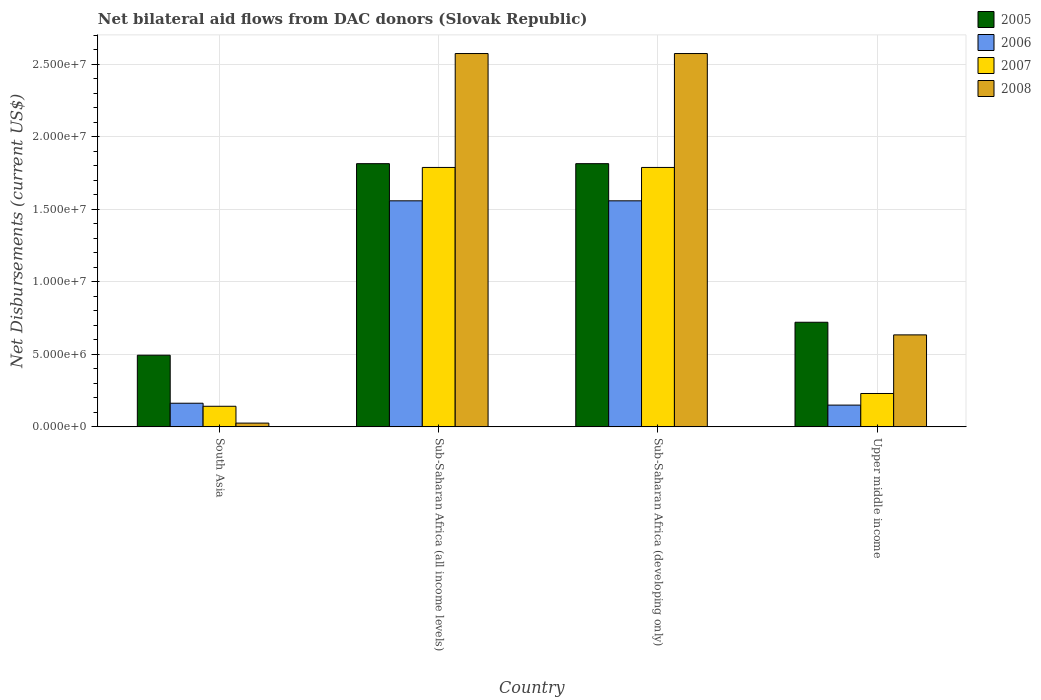How many different coloured bars are there?
Your answer should be very brief. 4. How many groups of bars are there?
Keep it short and to the point. 4. What is the label of the 2nd group of bars from the left?
Offer a terse response. Sub-Saharan Africa (all income levels). What is the net bilateral aid flows in 2008 in Sub-Saharan Africa (all income levels)?
Provide a succinct answer. 2.57e+07. Across all countries, what is the maximum net bilateral aid flows in 2006?
Give a very brief answer. 1.56e+07. Across all countries, what is the minimum net bilateral aid flows in 2007?
Provide a succinct answer. 1.42e+06. In which country was the net bilateral aid flows in 2008 maximum?
Provide a short and direct response. Sub-Saharan Africa (all income levels). In which country was the net bilateral aid flows in 2005 minimum?
Your response must be concise. South Asia. What is the total net bilateral aid flows in 2008 in the graph?
Offer a terse response. 5.81e+07. What is the difference between the net bilateral aid flows in 2008 in South Asia and that in Upper middle income?
Offer a very short reply. -6.08e+06. What is the difference between the net bilateral aid flows in 2007 in Sub-Saharan Africa (developing only) and the net bilateral aid flows in 2008 in Sub-Saharan Africa (all income levels)?
Provide a succinct answer. -7.85e+06. What is the average net bilateral aid flows in 2008 per country?
Give a very brief answer. 1.45e+07. What is the difference between the net bilateral aid flows of/in 2005 and net bilateral aid flows of/in 2008 in Sub-Saharan Africa (developing only)?
Your response must be concise. -7.59e+06. What is the ratio of the net bilateral aid flows in 2008 in South Asia to that in Sub-Saharan Africa (all income levels)?
Your response must be concise. 0.01. What is the difference between the highest and the second highest net bilateral aid flows in 2007?
Provide a short and direct response. 1.56e+07. What is the difference between the highest and the lowest net bilateral aid flows in 2006?
Offer a very short reply. 1.41e+07. Is the sum of the net bilateral aid flows in 2005 in Sub-Saharan Africa (all income levels) and Sub-Saharan Africa (developing only) greater than the maximum net bilateral aid flows in 2008 across all countries?
Make the answer very short. Yes. Is it the case that in every country, the sum of the net bilateral aid flows in 2008 and net bilateral aid flows in 2007 is greater than the sum of net bilateral aid flows in 2006 and net bilateral aid flows in 2005?
Provide a succinct answer. No. What does the 4th bar from the left in Upper middle income represents?
Your answer should be very brief. 2008. Is it the case that in every country, the sum of the net bilateral aid flows in 2006 and net bilateral aid flows in 2005 is greater than the net bilateral aid flows in 2007?
Your answer should be compact. Yes. How many bars are there?
Keep it short and to the point. 16. Are all the bars in the graph horizontal?
Your answer should be very brief. No. Are the values on the major ticks of Y-axis written in scientific E-notation?
Offer a very short reply. Yes. Does the graph contain any zero values?
Keep it short and to the point. No. Does the graph contain grids?
Offer a terse response. Yes. Where does the legend appear in the graph?
Provide a short and direct response. Top right. How many legend labels are there?
Your answer should be compact. 4. How are the legend labels stacked?
Provide a succinct answer. Vertical. What is the title of the graph?
Offer a very short reply. Net bilateral aid flows from DAC donors (Slovak Republic). Does "2006" appear as one of the legend labels in the graph?
Keep it short and to the point. Yes. What is the label or title of the X-axis?
Ensure brevity in your answer.  Country. What is the label or title of the Y-axis?
Provide a short and direct response. Net Disbursements (current US$). What is the Net Disbursements (current US$) in 2005 in South Asia?
Provide a succinct answer. 4.94e+06. What is the Net Disbursements (current US$) of 2006 in South Asia?
Your answer should be compact. 1.63e+06. What is the Net Disbursements (current US$) of 2007 in South Asia?
Offer a terse response. 1.42e+06. What is the Net Disbursements (current US$) in 2005 in Sub-Saharan Africa (all income levels)?
Keep it short and to the point. 1.81e+07. What is the Net Disbursements (current US$) in 2006 in Sub-Saharan Africa (all income levels)?
Your answer should be compact. 1.56e+07. What is the Net Disbursements (current US$) in 2007 in Sub-Saharan Africa (all income levels)?
Keep it short and to the point. 1.79e+07. What is the Net Disbursements (current US$) in 2008 in Sub-Saharan Africa (all income levels)?
Your response must be concise. 2.57e+07. What is the Net Disbursements (current US$) of 2005 in Sub-Saharan Africa (developing only)?
Your response must be concise. 1.81e+07. What is the Net Disbursements (current US$) in 2006 in Sub-Saharan Africa (developing only)?
Make the answer very short. 1.56e+07. What is the Net Disbursements (current US$) in 2007 in Sub-Saharan Africa (developing only)?
Offer a very short reply. 1.79e+07. What is the Net Disbursements (current US$) in 2008 in Sub-Saharan Africa (developing only)?
Ensure brevity in your answer.  2.57e+07. What is the Net Disbursements (current US$) in 2005 in Upper middle income?
Your response must be concise. 7.21e+06. What is the Net Disbursements (current US$) of 2006 in Upper middle income?
Your answer should be very brief. 1.50e+06. What is the Net Disbursements (current US$) in 2007 in Upper middle income?
Keep it short and to the point. 2.30e+06. What is the Net Disbursements (current US$) of 2008 in Upper middle income?
Offer a very short reply. 6.34e+06. Across all countries, what is the maximum Net Disbursements (current US$) of 2005?
Offer a very short reply. 1.81e+07. Across all countries, what is the maximum Net Disbursements (current US$) of 2006?
Make the answer very short. 1.56e+07. Across all countries, what is the maximum Net Disbursements (current US$) of 2007?
Your answer should be compact. 1.79e+07. Across all countries, what is the maximum Net Disbursements (current US$) of 2008?
Give a very brief answer. 2.57e+07. Across all countries, what is the minimum Net Disbursements (current US$) of 2005?
Your answer should be very brief. 4.94e+06. Across all countries, what is the minimum Net Disbursements (current US$) of 2006?
Give a very brief answer. 1.50e+06. Across all countries, what is the minimum Net Disbursements (current US$) of 2007?
Keep it short and to the point. 1.42e+06. Across all countries, what is the minimum Net Disbursements (current US$) of 2008?
Offer a very short reply. 2.60e+05. What is the total Net Disbursements (current US$) in 2005 in the graph?
Your answer should be compact. 4.84e+07. What is the total Net Disbursements (current US$) of 2006 in the graph?
Your answer should be very brief. 3.43e+07. What is the total Net Disbursements (current US$) of 2007 in the graph?
Provide a succinct answer. 3.95e+07. What is the total Net Disbursements (current US$) in 2008 in the graph?
Your response must be concise. 5.81e+07. What is the difference between the Net Disbursements (current US$) in 2005 in South Asia and that in Sub-Saharan Africa (all income levels)?
Your response must be concise. -1.32e+07. What is the difference between the Net Disbursements (current US$) of 2006 in South Asia and that in Sub-Saharan Africa (all income levels)?
Your response must be concise. -1.40e+07. What is the difference between the Net Disbursements (current US$) of 2007 in South Asia and that in Sub-Saharan Africa (all income levels)?
Provide a short and direct response. -1.65e+07. What is the difference between the Net Disbursements (current US$) in 2008 in South Asia and that in Sub-Saharan Africa (all income levels)?
Your response must be concise. -2.55e+07. What is the difference between the Net Disbursements (current US$) in 2005 in South Asia and that in Sub-Saharan Africa (developing only)?
Offer a very short reply. -1.32e+07. What is the difference between the Net Disbursements (current US$) of 2006 in South Asia and that in Sub-Saharan Africa (developing only)?
Provide a succinct answer. -1.40e+07. What is the difference between the Net Disbursements (current US$) of 2007 in South Asia and that in Sub-Saharan Africa (developing only)?
Your answer should be very brief. -1.65e+07. What is the difference between the Net Disbursements (current US$) in 2008 in South Asia and that in Sub-Saharan Africa (developing only)?
Give a very brief answer. -2.55e+07. What is the difference between the Net Disbursements (current US$) in 2005 in South Asia and that in Upper middle income?
Offer a terse response. -2.27e+06. What is the difference between the Net Disbursements (current US$) of 2007 in South Asia and that in Upper middle income?
Your answer should be very brief. -8.80e+05. What is the difference between the Net Disbursements (current US$) in 2008 in South Asia and that in Upper middle income?
Make the answer very short. -6.08e+06. What is the difference between the Net Disbursements (current US$) in 2005 in Sub-Saharan Africa (all income levels) and that in Sub-Saharan Africa (developing only)?
Your answer should be very brief. 0. What is the difference between the Net Disbursements (current US$) in 2005 in Sub-Saharan Africa (all income levels) and that in Upper middle income?
Your answer should be compact. 1.09e+07. What is the difference between the Net Disbursements (current US$) in 2006 in Sub-Saharan Africa (all income levels) and that in Upper middle income?
Provide a short and direct response. 1.41e+07. What is the difference between the Net Disbursements (current US$) of 2007 in Sub-Saharan Africa (all income levels) and that in Upper middle income?
Offer a terse response. 1.56e+07. What is the difference between the Net Disbursements (current US$) of 2008 in Sub-Saharan Africa (all income levels) and that in Upper middle income?
Offer a terse response. 1.94e+07. What is the difference between the Net Disbursements (current US$) in 2005 in Sub-Saharan Africa (developing only) and that in Upper middle income?
Provide a succinct answer. 1.09e+07. What is the difference between the Net Disbursements (current US$) of 2006 in Sub-Saharan Africa (developing only) and that in Upper middle income?
Offer a terse response. 1.41e+07. What is the difference between the Net Disbursements (current US$) of 2007 in Sub-Saharan Africa (developing only) and that in Upper middle income?
Your response must be concise. 1.56e+07. What is the difference between the Net Disbursements (current US$) of 2008 in Sub-Saharan Africa (developing only) and that in Upper middle income?
Keep it short and to the point. 1.94e+07. What is the difference between the Net Disbursements (current US$) of 2005 in South Asia and the Net Disbursements (current US$) of 2006 in Sub-Saharan Africa (all income levels)?
Provide a succinct answer. -1.06e+07. What is the difference between the Net Disbursements (current US$) of 2005 in South Asia and the Net Disbursements (current US$) of 2007 in Sub-Saharan Africa (all income levels)?
Your response must be concise. -1.29e+07. What is the difference between the Net Disbursements (current US$) in 2005 in South Asia and the Net Disbursements (current US$) in 2008 in Sub-Saharan Africa (all income levels)?
Ensure brevity in your answer.  -2.08e+07. What is the difference between the Net Disbursements (current US$) of 2006 in South Asia and the Net Disbursements (current US$) of 2007 in Sub-Saharan Africa (all income levels)?
Ensure brevity in your answer.  -1.62e+07. What is the difference between the Net Disbursements (current US$) in 2006 in South Asia and the Net Disbursements (current US$) in 2008 in Sub-Saharan Africa (all income levels)?
Provide a short and direct response. -2.41e+07. What is the difference between the Net Disbursements (current US$) in 2007 in South Asia and the Net Disbursements (current US$) in 2008 in Sub-Saharan Africa (all income levels)?
Offer a very short reply. -2.43e+07. What is the difference between the Net Disbursements (current US$) of 2005 in South Asia and the Net Disbursements (current US$) of 2006 in Sub-Saharan Africa (developing only)?
Keep it short and to the point. -1.06e+07. What is the difference between the Net Disbursements (current US$) of 2005 in South Asia and the Net Disbursements (current US$) of 2007 in Sub-Saharan Africa (developing only)?
Your answer should be very brief. -1.29e+07. What is the difference between the Net Disbursements (current US$) in 2005 in South Asia and the Net Disbursements (current US$) in 2008 in Sub-Saharan Africa (developing only)?
Your response must be concise. -2.08e+07. What is the difference between the Net Disbursements (current US$) of 2006 in South Asia and the Net Disbursements (current US$) of 2007 in Sub-Saharan Africa (developing only)?
Provide a short and direct response. -1.62e+07. What is the difference between the Net Disbursements (current US$) of 2006 in South Asia and the Net Disbursements (current US$) of 2008 in Sub-Saharan Africa (developing only)?
Offer a terse response. -2.41e+07. What is the difference between the Net Disbursements (current US$) of 2007 in South Asia and the Net Disbursements (current US$) of 2008 in Sub-Saharan Africa (developing only)?
Your answer should be very brief. -2.43e+07. What is the difference between the Net Disbursements (current US$) in 2005 in South Asia and the Net Disbursements (current US$) in 2006 in Upper middle income?
Your response must be concise. 3.44e+06. What is the difference between the Net Disbursements (current US$) of 2005 in South Asia and the Net Disbursements (current US$) of 2007 in Upper middle income?
Provide a short and direct response. 2.64e+06. What is the difference between the Net Disbursements (current US$) in 2005 in South Asia and the Net Disbursements (current US$) in 2008 in Upper middle income?
Keep it short and to the point. -1.40e+06. What is the difference between the Net Disbursements (current US$) in 2006 in South Asia and the Net Disbursements (current US$) in 2007 in Upper middle income?
Your answer should be compact. -6.70e+05. What is the difference between the Net Disbursements (current US$) of 2006 in South Asia and the Net Disbursements (current US$) of 2008 in Upper middle income?
Keep it short and to the point. -4.71e+06. What is the difference between the Net Disbursements (current US$) of 2007 in South Asia and the Net Disbursements (current US$) of 2008 in Upper middle income?
Make the answer very short. -4.92e+06. What is the difference between the Net Disbursements (current US$) of 2005 in Sub-Saharan Africa (all income levels) and the Net Disbursements (current US$) of 2006 in Sub-Saharan Africa (developing only)?
Your answer should be very brief. 2.56e+06. What is the difference between the Net Disbursements (current US$) of 2005 in Sub-Saharan Africa (all income levels) and the Net Disbursements (current US$) of 2008 in Sub-Saharan Africa (developing only)?
Your answer should be compact. -7.59e+06. What is the difference between the Net Disbursements (current US$) in 2006 in Sub-Saharan Africa (all income levels) and the Net Disbursements (current US$) in 2007 in Sub-Saharan Africa (developing only)?
Your response must be concise. -2.30e+06. What is the difference between the Net Disbursements (current US$) in 2006 in Sub-Saharan Africa (all income levels) and the Net Disbursements (current US$) in 2008 in Sub-Saharan Africa (developing only)?
Make the answer very short. -1.02e+07. What is the difference between the Net Disbursements (current US$) of 2007 in Sub-Saharan Africa (all income levels) and the Net Disbursements (current US$) of 2008 in Sub-Saharan Africa (developing only)?
Your answer should be compact. -7.85e+06. What is the difference between the Net Disbursements (current US$) of 2005 in Sub-Saharan Africa (all income levels) and the Net Disbursements (current US$) of 2006 in Upper middle income?
Your answer should be very brief. 1.66e+07. What is the difference between the Net Disbursements (current US$) in 2005 in Sub-Saharan Africa (all income levels) and the Net Disbursements (current US$) in 2007 in Upper middle income?
Your answer should be compact. 1.58e+07. What is the difference between the Net Disbursements (current US$) of 2005 in Sub-Saharan Africa (all income levels) and the Net Disbursements (current US$) of 2008 in Upper middle income?
Provide a short and direct response. 1.18e+07. What is the difference between the Net Disbursements (current US$) in 2006 in Sub-Saharan Africa (all income levels) and the Net Disbursements (current US$) in 2007 in Upper middle income?
Make the answer very short. 1.33e+07. What is the difference between the Net Disbursements (current US$) of 2006 in Sub-Saharan Africa (all income levels) and the Net Disbursements (current US$) of 2008 in Upper middle income?
Give a very brief answer. 9.24e+06. What is the difference between the Net Disbursements (current US$) of 2007 in Sub-Saharan Africa (all income levels) and the Net Disbursements (current US$) of 2008 in Upper middle income?
Provide a short and direct response. 1.15e+07. What is the difference between the Net Disbursements (current US$) in 2005 in Sub-Saharan Africa (developing only) and the Net Disbursements (current US$) in 2006 in Upper middle income?
Ensure brevity in your answer.  1.66e+07. What is the difference between the Net Disbursements (current US$) of 2005 in Sub-Saharan Africa (developing only) and the Net Disbursements (current US$) of 2007 in Upper middle income?
Provide a succinct answer. 1.58e+07. What is the difference between the Net Disbursements (current US$) of 2005 in Sub-Saharan Africa (developing only) and the Net Disbursements (current US$) of 2008 in Upper middle income?
Make the answer very short. 1.18e+07. What is the difference between the Net Disbursements (current US$) in 2006 in Sub-Saharan Africa (developing only) and the Net Disbursements (current US$) in 2007 in Upper middle income?
Offer a terse response. 1.33e+07. What is the difference between the Net Disbursements (current US$) of 2006 in Sub-Saharan Africa (developing only) and the Net Disbursements (current US$) of 2008 in Upper middle income?
Your answer should be compact. 9.24e+06. What is the difference between the Net Disbursements (current US$) of 2007 in Sub-Saharan Africa (developing only) and the Net Disbursements (current US$) of 2008 in Upper middle income?
Ensure brevity in your answer.  1.15e+07. What is the average Net Disbursements (current US$) in 2005 per country?
Your answer should be compact. 1.21e+07. What is the average Net Disbursements (current US$) of 2006 per country?
Your answer should be very brief. 8.57e+06. What is the average Net Disbursements (current US$) in 2007 per country?
Provide a short and direct response. 9.87e+06. What is the average Net Disbursements (current US$) of 2008 per country?
Ensure brevity in your answer.  1.45e+07. What is the difference between the Net Disbursements (current US$) in 2005 and Net Disbursements (current US$) in 2006 in South Asia?
Ensure brevity in your answer.  3.31e+06. What is the difference between the Net Disbursements (current US$) of 2005 and Net Disbursements (current US$) of 2007 in South Asia?
Give a very brief answer. 3.52e+06. What is the difference between the Net Disbursements (current US$) in 2005 and Net Disbursements (current US$) in 2008 in South Asia?
Offer a terse response. 4.68e+06. What is the difference between the Net Disbursements (current US$) of 2006 and Net Disbursements (current US$) of 2008 in South Asia?
Provide a succinct answer. 1.37e+06. What is the difference between the Net Disbursements (current US$) in 2007 and Net Disbursements (current US$) in 2008 in South Asia?
Keep it short and to the point. 1.16e+06. What is the difference between the Net Disbursements (current US$) in 2005 and Net Disbursements (current US$) in 2006 in Sub-Saharan Africa (all income levels)?
Provide a short and direct response. 2.56e+06. What is the difference between the Net Disbursements (current US$) in 2005 and Net Disbursements (current US$) in 2007 in Sub-Saharan Africa (all income levels)?
Offer a terse response. 2.60e+05. What is the difference between the Net Disbursements (current US$) in 2005 and Net Disbursements (current US$) in 2008 in Sub-Saharan Africa (all income levels)?
Provide a short and direct response. -7.59e+06. What is the difference between the Net Disbursements (current US$) of 2006 and Net Disbursements (current US$) of 2007 in Sub-Saharan Africa (all income levels)?
Keep it short and to the point. -2.30e+06. What is the difference between the Net Disbursements (current US$) of 2006 and Net Disbursements (current US$) of 2008 in Sub-Saharan Africa (all income levels)?
Give a very brief answer. -1.02e+07. What is the difference between the Net Disbursements (current US$) in 2007 and Net Disbursements (current US$) in 2008 in Sub-Saharan Africa (all income levels)?
Make the answer very short. -7.85e+06. What is the difference between the Net Disbursements (current US$) of 2005 and Net Disbursements (current US$) of 2006 in Sub-Saharan Africa (developing only)?
Provide a succinct answer. 2.56e+06. What is the difference between the Net Disbursements (current US$) in 2005 and Net Disbursements (current US$) in 2007 in Sub-Saharan Africa (developing only)?
Give a very brief answer. 2.60e+05. What is the difference between the Net Disbursements (current US$) of 2005 and Net Disbursements (current US$) of 2008 in Sub-Saharan Africa (developing only)?
Offer a terse response. -7.59e+06. What is the difference between the Net Disbursements (current US$) of 2006 and Net Disbursements (current US$) of 2007 in Sub-Saharan Africa (developing only)?
Provide a short and direct response. -2.30e+06. What is the difference between the Net Disbursements (current US$) of 2006 and Net Disbursements (current US$) of 2008 in Sub-Saharan Africa (developing only)?
Make the answer very short. -1.02e+07. What is the difference between the Net Disbursements (current US$) in 2007 and Net Disbursements (current US$) in 2008 in Sub-Saharan Africa (developing only)?
Keep it short and to the point. -7.85e+06. What is the difference between the Net Disbursements (current US$) of 2005 and Net Disbursements (current US$) of 2006 in Upper middle income?
Make the answer very short. 5.71e+06. What is the difference between the Net Disbursements (current US$) in 2005 and Net Disbursements (current US$) in 2007 in Upper middle income?
Offer a terse response. 4.91e+06. What is the difference between the Net Disbursements (current US$) of 2005 and Net Disbursements (current US$) of 2008 in Upper middle income?
Your answer should be compact. 8.70e+05. What is the difference between the Net Disbursements (current US$) of 2006 and Net Disbursements (current US$) of 2007 in Upper middle income?
Your answer should be very brief. -8.00e+05. What is the difference between the Net Disbursements (current US$) of 2006 and Net Disbursements (current US$) of 2008 in Upper middle income?
Provide a short and direct response. -4.84e+06. What is the difference between the Net Disbursements (current US$) of 2007 and Net Disbursements (current US$) of 2008 in Upper middle income?
Provide a short and direct response. -4.04e+06. What is the ratio of the Net Disbursements (current US$) in 2005 in South Asia to that in Sub-Saharan Africa (all income levels)?
Your answer should be very brief. 0.27. What is the ratio of the Net Disbursements (current US$) of 2006 in South Asia to that in Sub-Saharan Africa (all income levels)?
Provide a succinct answer. 0.1. What is the ratio of the Net Disbursements (current US$) of 2007 in South Asia to that in Sub-Saharan Africa (all income levels)?
Offer a terse response. 0.08. What is the ratio of the Net Disbursements (current US$) of 2008 in South Asia to that in Sub-Saharan Africa (all income levels)?
Your answer should be compact. 0.01. What is the ratio of the Net Disbursements (current US$) of 2005 in South Asia to that in Sub-Saharan Africa (developing only)?
Keep it short and to the point. 0.27. What is the ratio of the Net Disbursements (current US$) of 2006 in South Asia to that in Sub-Saharan Africa (developing only)?
Your answer should be compact. 0.1. What is the ratio of the Net Disbursements (current US$) in 2007 in South Asia to that in Sub-Saharan Africa (developing only)?
Your answer should be compact. 0.08. What is the ratio of the Net Disbursements (current US$) of 2008 in South Asia to that in Sub-Saharan Africa (developing only)?
Make the answer very short. 0.01. What is the ratio of the Net Disbursements (current US$) of 2005 in South Asia to that in Upper middle income?
Offer a terse response. 0.69. What is the ratio of the Net Disbursements (current US$) in 2006 in South Asia to that in Upper middle income?
Offer a terse response. 1.09. What is the ratio of the Net Disbursements (current US$) in 2007 in South Asia to that in Upper middle income?
Your answer should be compact. 0.62. What is the ratio of the Net Disbursements (current US$) of 2008 in South Asia to that in Upper middle income?
Ensure brevity in your answer.  0.04. What is the ratio of the Net Disbursements (current US$) of 2006 in Sub-Saharan Africa (all income levels) to that in Sub-Saharan Africa (developing only)?
Offer a very short reply. 1. What is the ratio of the Net Disbursements (current US$) in 2005 in Sub-Saharan Africa (all income levels) to that in Upper middle income?
Provide a short and direct response. 2.52. What is the ratio of the Net Disbursements (current US$) in 2006 in Sub-Saharan Africa (all income levels) to that in Upper middle income?
Keep it short and to the point. 10.39. What is the ratio of the Net Disbursements (current US$) of 2007 in Sub-Saharan Africa (all income levels) to that in Upper middle income?
Make the answer very short. 7.77. What is the ratio of the Net Disbursements (current US$) in 2008 in Sub-Saharan Africa (all income levels) to that in Upper middle income?
Offer a very short reply. 4.06. What is the ratio of the Net Disbursements (current US$) in 2005 in Sub-Saharan Africa (developing only) to that in Upper middle income?
Offer a terse response. 2.52. What is the ratio of the Net Disbursements (current US$) of 2006 in Sub-Saharan Africa (developing only) to that in Upper middle income?
Offer a terse response. 10.39. What is the ratio of the Net Disbursements (current US$) in 2007 in Sub-Saharan Africa (developing only) to that in Upper middle income?
Your response must be concise. 7.77. What is the ratio of the Net Disbursements (current US$) of 2008 in Sub-Saharan Africa (developing only) to that in Upper middle income?
Provide a succinct answer. 4.06. What is the difference between the highest and the second highest Net Disbursements (current US$) in 2005?
Keep it short and to the point. 0. What is the difference between the highest and the second highest Net Disbursements (current US$) of 2006?
Provide a short and direct response. 0. What is the difference between the highest and the second highest Net Disbursements (current US$) of 2007?
Offer a very short reply. 0. What is the difference between the highest and the lowest Net Disbursements (current US$) of 2005?
Your answer should be compact. 1.32e+07. What is the difference between the highest and the lowest Net Disbursements (current US$) of 2006?
Provide a short and direct response. 1.41e+07. What is the difference between the highest and the lowest Net Disbursements (current US$) of 2007?
Offer a very short reply. 1.65e+07. What is the difference between the highest and the lowest Net Disbursements (current US$) of 2008?
Your answer should be very brief. 2.55e+07. 